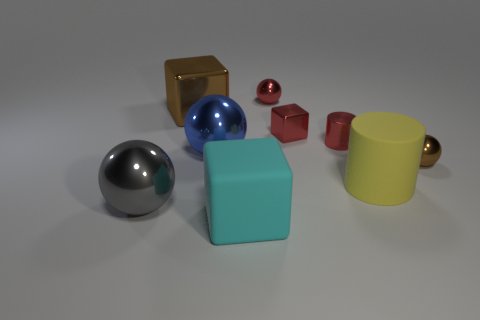What number of objects are large gray cylinders or metallic things?
Make the answer very short. 7. Is the size of the yellow cylinder the same as the thing in front of the big gray metallic ball?
Your response must be concise. Yes. What color is the tiny metal ball behind the shiny sphere on the right side of the big object to the right of the red ball?
Your answer should be very brief. Red. What color is the shiny cylinder?
Your answer should be compact. Red. Are there more big gray metal objects that are behind the brown block than small brown things in front of the cyan matte thing?
Provide a succinct answer. No. There is a blue shiny thing; is its shape the same as the brown metallic thing to the left of the tiny brown metal thing?
Your answer should be very brief. No. Is the size of the rubber object that is right of the red block the same as the object in front of the big gray object?
Your response must be concise. Yes. There is a big block that is in front of the large metal thing in front of the yellow matte cylinder; is there a shiny cylinder that is on the left side of it?
Ensure brevity in your answer.  No. Are there fewer cyan matte objects on the left side of the large brown block than big blue spheres that are on the right side of the gray thing?
Provide a succinct answer. Yes. There is a large brown thing that is the same material as the tiny red cylinder; what shape is it?
Offer a very short reply. Cube. 